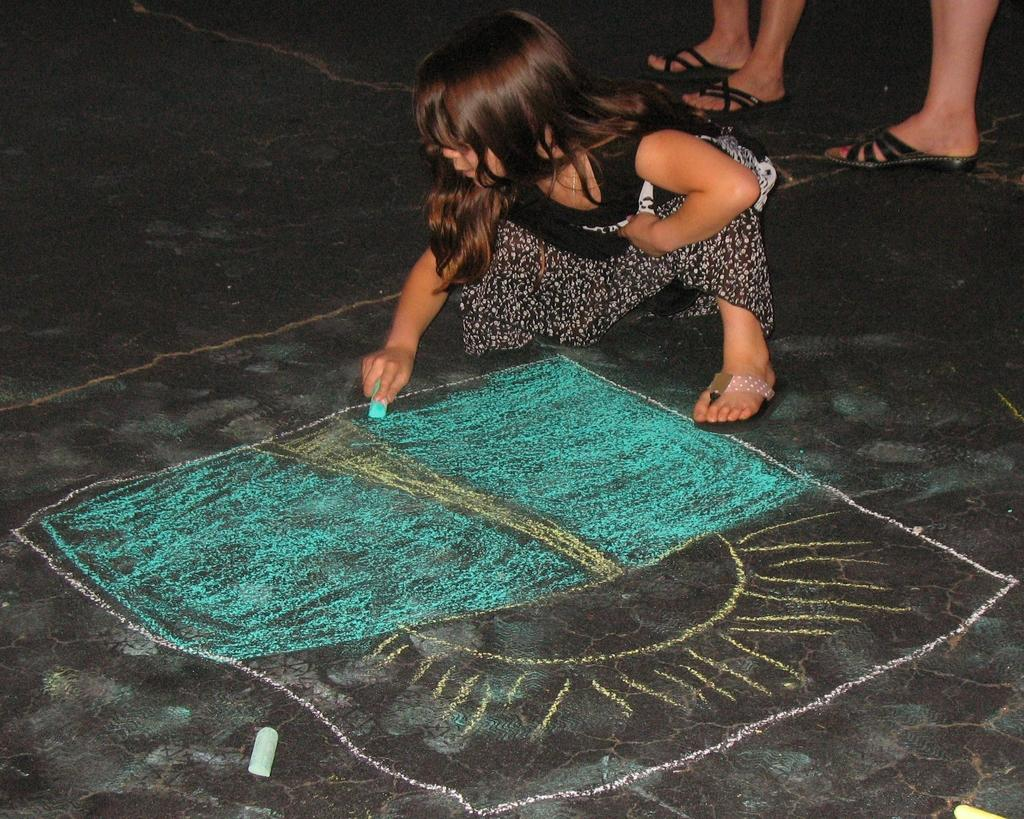Who is the main subject in the image? There is a girl in the image. What is the girl doing in the image? The girl is drawing on the ground. What tool is the girl using to draw? The girl is using chalk to draw. Can you describe the chalk in the image? There is a chalk on the ground. What else can be seen at the right side of the image? There are legs of persons visible at the right side of the image, which suggests that there are other people nearby. What type of current is flowing through the girl's drawing in the image? There is no current flowing through the girl's drawing in the image; it is a static drawing made with chalk. What story is the girl telling with her drawing in the image? There is no indication of a story being told through the girl's drawing in the image; it is simply a drawing made with chalk. 